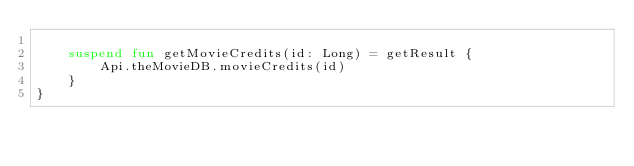<code> <loc_0><loc_0><loc_500><loc_500><_Kotlin_>
    suspend fun getMovieCredits(id: Long) = getResult {
        Api.theMovieDB.movieCredits(id)
    }
}</code> 